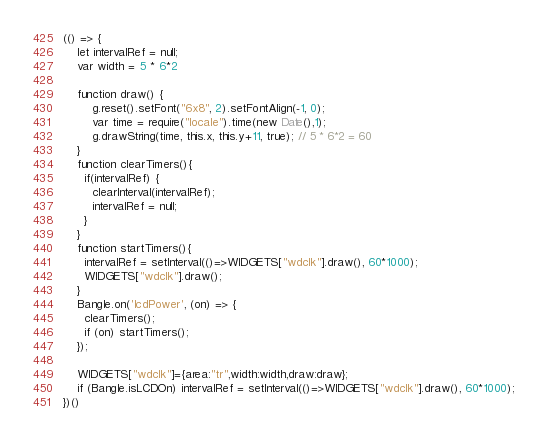<code> <loc_0><loc_0><loc_500><loc_500><_JavaScript_>(() => {
    let intervalRef = null;
    var width = 5 * 6*2

    function draw() {
        g.reset().setFont("6x8", 2).setFontAlign(-1, 0);
        var time = require("locale").time(new Date(),1);
        g.drawString(time, this.x, this.y+11, true); // 5 * 6*2 = 60
    }
    function clearTimers(){
      if(intervalRef) {
        clearInterval(intervalRef);
        intervalRef = null;
      }
    }
    function startTimers(){
      intervalRef = setInterval(()=>WIDGETS["wdclk"].draw(), 60*1000);
      WIDGETS["wdclk"].draw();
    }
    Bangle.on('lcdPower', (on) => {
      clearTimers();
      if (on) startTimers();
    });

    WIDGETS["wdclk"]={area:"tr",width:width,draw:draw};
    if (Bangle.isLCDOn) intervalRef = setInterval(()=>WIDGETS["wdclk"].draw(), 60*1000);
})()
</code> 